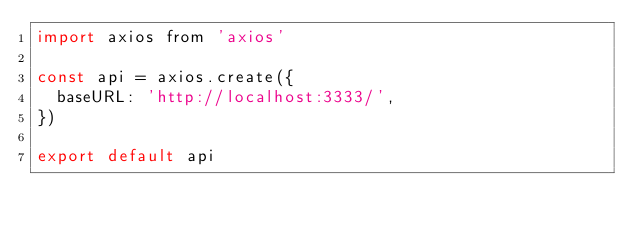<code> <loc_0><loc_0><loc_500><loc_500><_JavaScript_>import axios from 'axios'

const api = axios.create({
  baseURL: 'http://localhost:3333/',
})

export default api</code> 